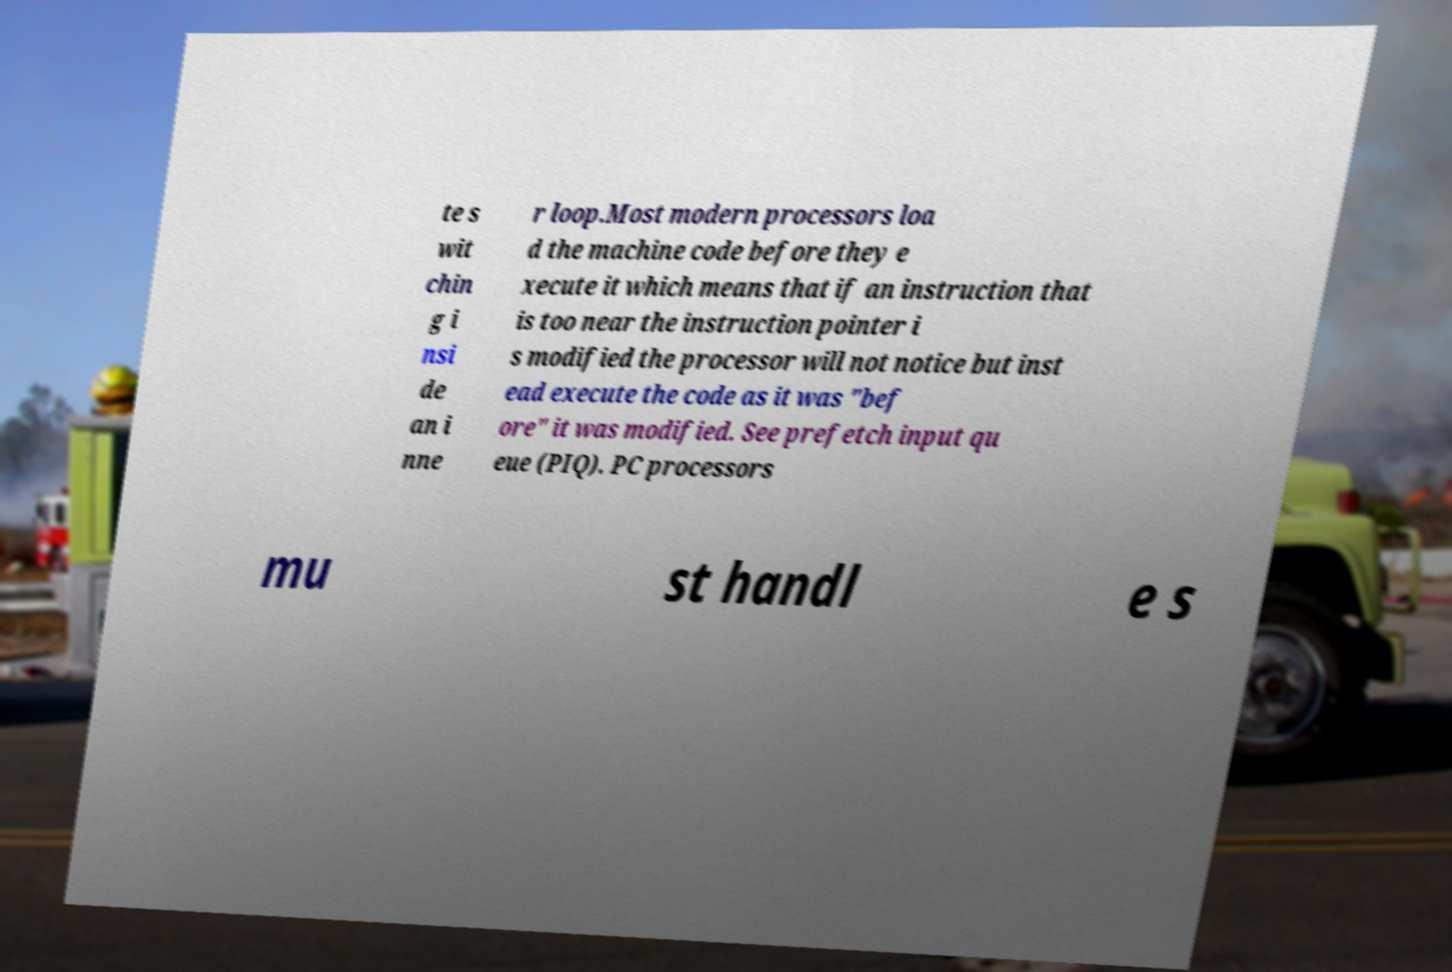Can you read and provide the text displayed in the image?This photo seems to have some interesting text. Can you extract and type it out for me? te s wit chin g i nsi de an i nne r loop.Most modern processors loa d the machine code before they e xecute it which means that if an instruction that is too near the instruction pointer i s modified the processor will not notice but inst ead execute the code as it was "bef ore" it was modified. See prefetch input qu eue (PIQ). PC processors mu st handl e s 